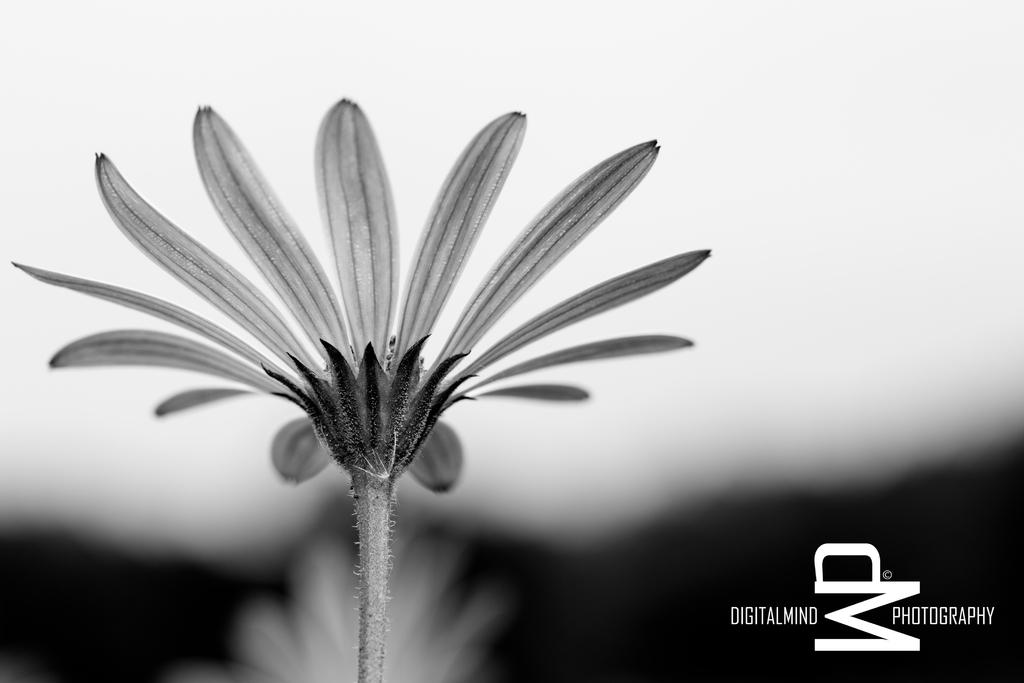What is the color scheme of the image? The image is black and white. What can be seen on the left side of the image? There is a flower on the left side of the image. How would you describe the background of the image? The background of the image is blurred. Where is the text located in the image? The text is in the bottom right corner of the image. What type of shade is covering the flower in the image? There is no shade covering the flower in the image; it is visible in the black and white setting. Can you see a rake in the image? There is no rake present in the image. 